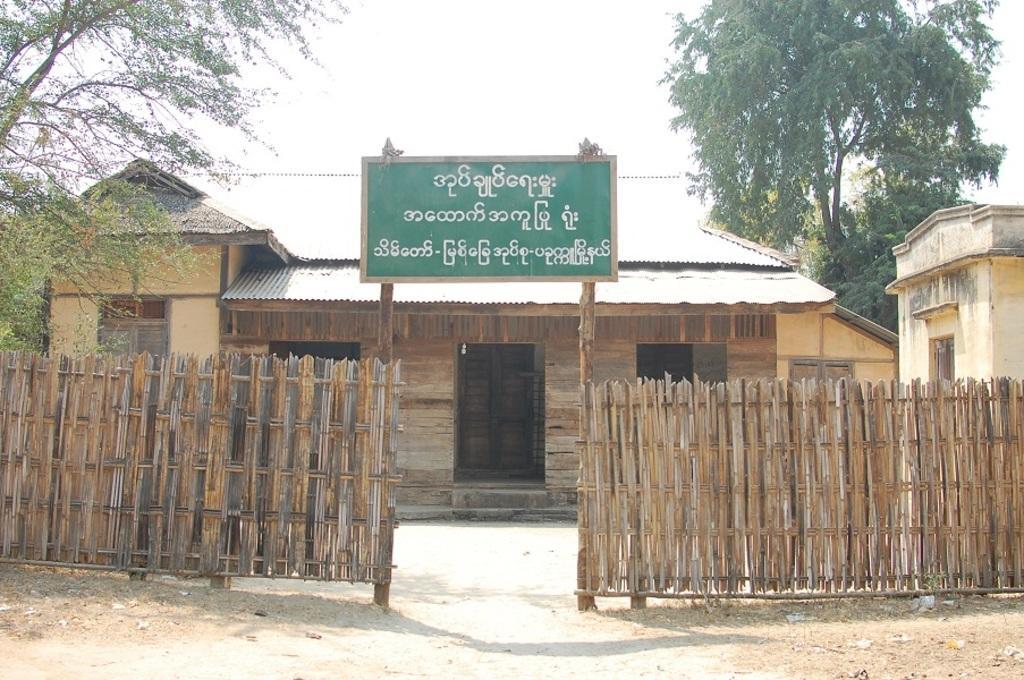In one or two sentences, can you explain what this image depicts? In this picture there are houses in the center of the image and there is a poster and a wooden boundary in front of the houses and there are trees on the right and left side of the image. 